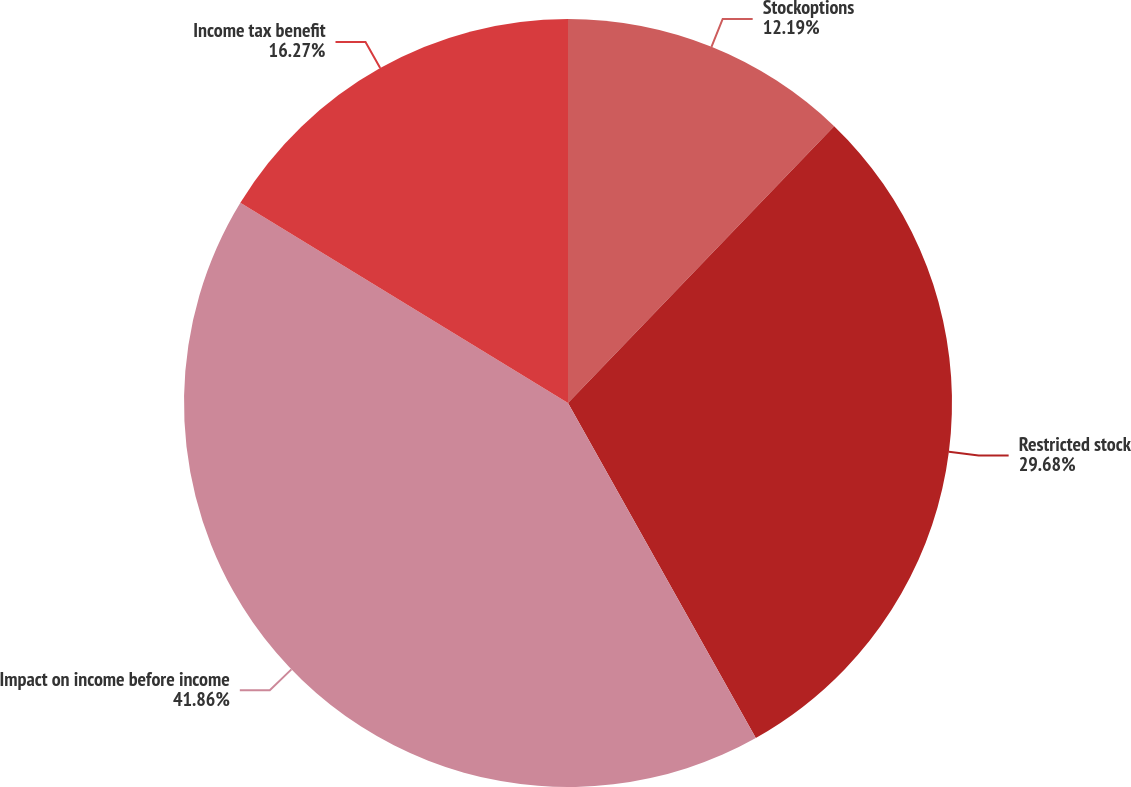Convert chart. <chart><loc_0><loc_0><loc_500><loc_500><pie_chart><fcel>Stockoptions<fcel>Restricted stock<fcel>Impact on income before income<fcel>Income tax benefit<nl><fcel>12.19%<fcel>29.68%<fcel>41.87%<fcel>16.27%<nl></chart> 